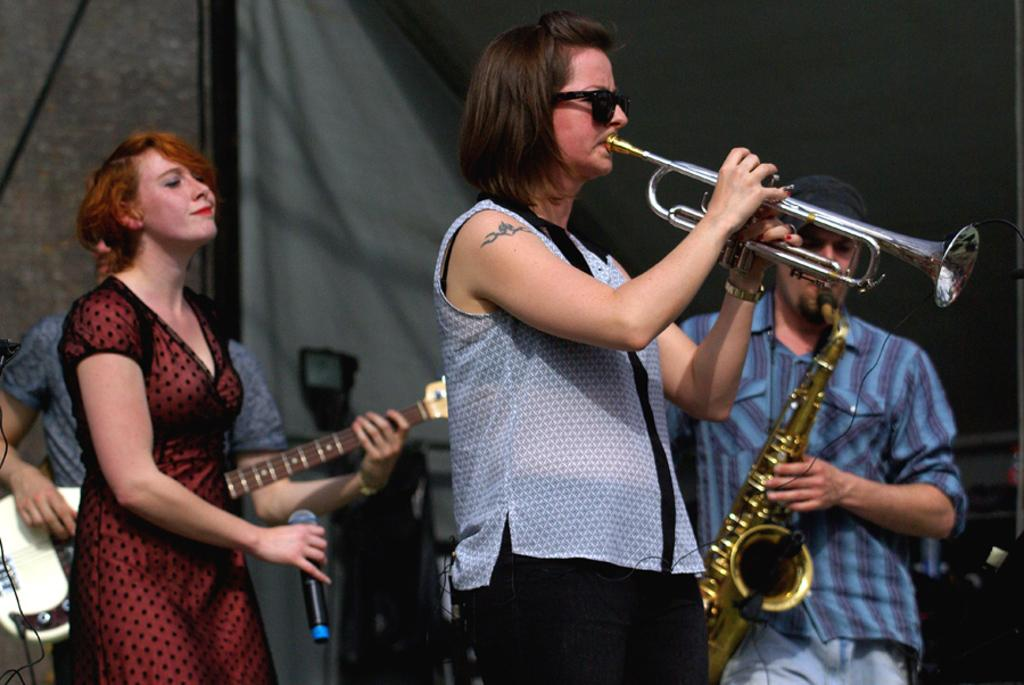How many people are in the image? There are four persons in the image. What are the persons doing in the image? The persons are playing musical instruments. Where is the scene taking place? The scene is on a stage. What can be seen in the background of the image? There is a wall and a curtain in the background of the image. What type of cheese is being used as a prop in the image? There is no cheese present in the image; the persons are playing musical instruments on a stage. 